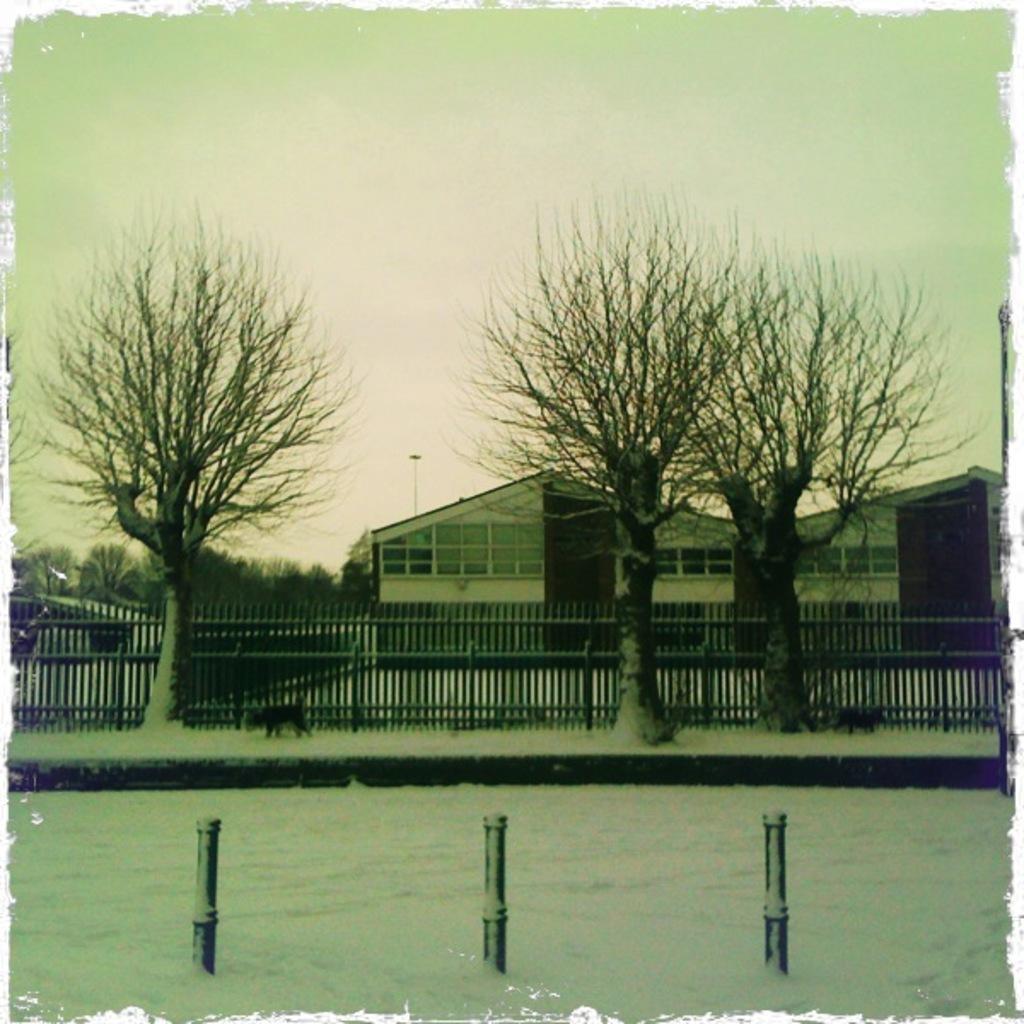Can you describe this image briefly? In this image I can see three poles. To the side of the poles I can see the railing and many trees. In the back I can see the houses and the sky. 